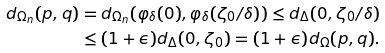<formula> <loc_0><loc_0><loc_500><loc_500>d _ { \Omega _ { n } } ( p , q ) & = d _ { \Omega _ { n } } ( \varphi _ { \delta } ( 0 ) , \varphi _ { \delta } ( \zeta _ { 0 } / \delta ) ) \leq d _ { \Delta } ( 0 , \zeta _ { 0 } / \delta ) \\ & \leq ( 1 + \epsilon ) d _ { \Delta } ( 0 , \zeta _ { 0 } ) = ( 1 + \epsilon ) d _ { \Omega } ( p , q ) .</formula> 